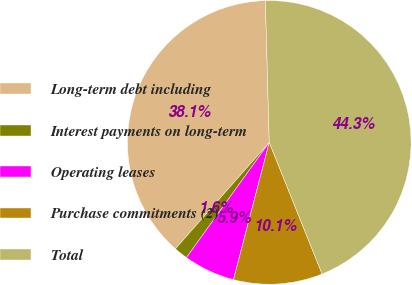Convert chart to OTSL. <chart><loc_0><loc_0><loc_500><loc_500><pie_chart><fcel>Long-term debt including<fcel>Interest payments on long-term<fcel>Operating leases<fcel>Purchase commitments (2)<fcel>Total<nl><fcel>38.07%<fcel>1.58%<fcel>5.86%<fcel>10.14%<fcel>44.35%<nl></chart> 